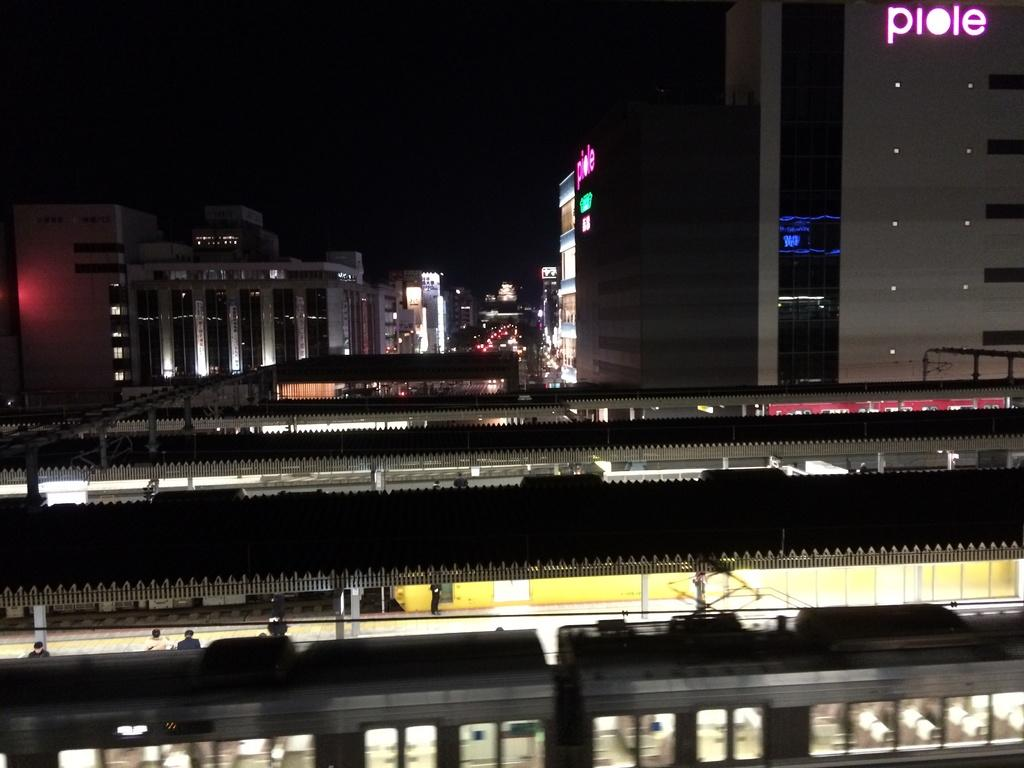<image>
Give a short and clear explanation of the subsequent image. A cityscape photo with the name piole in the top right corner. 